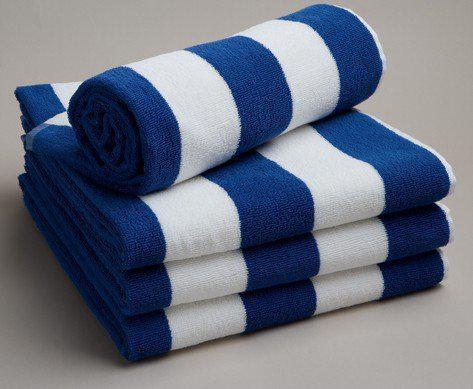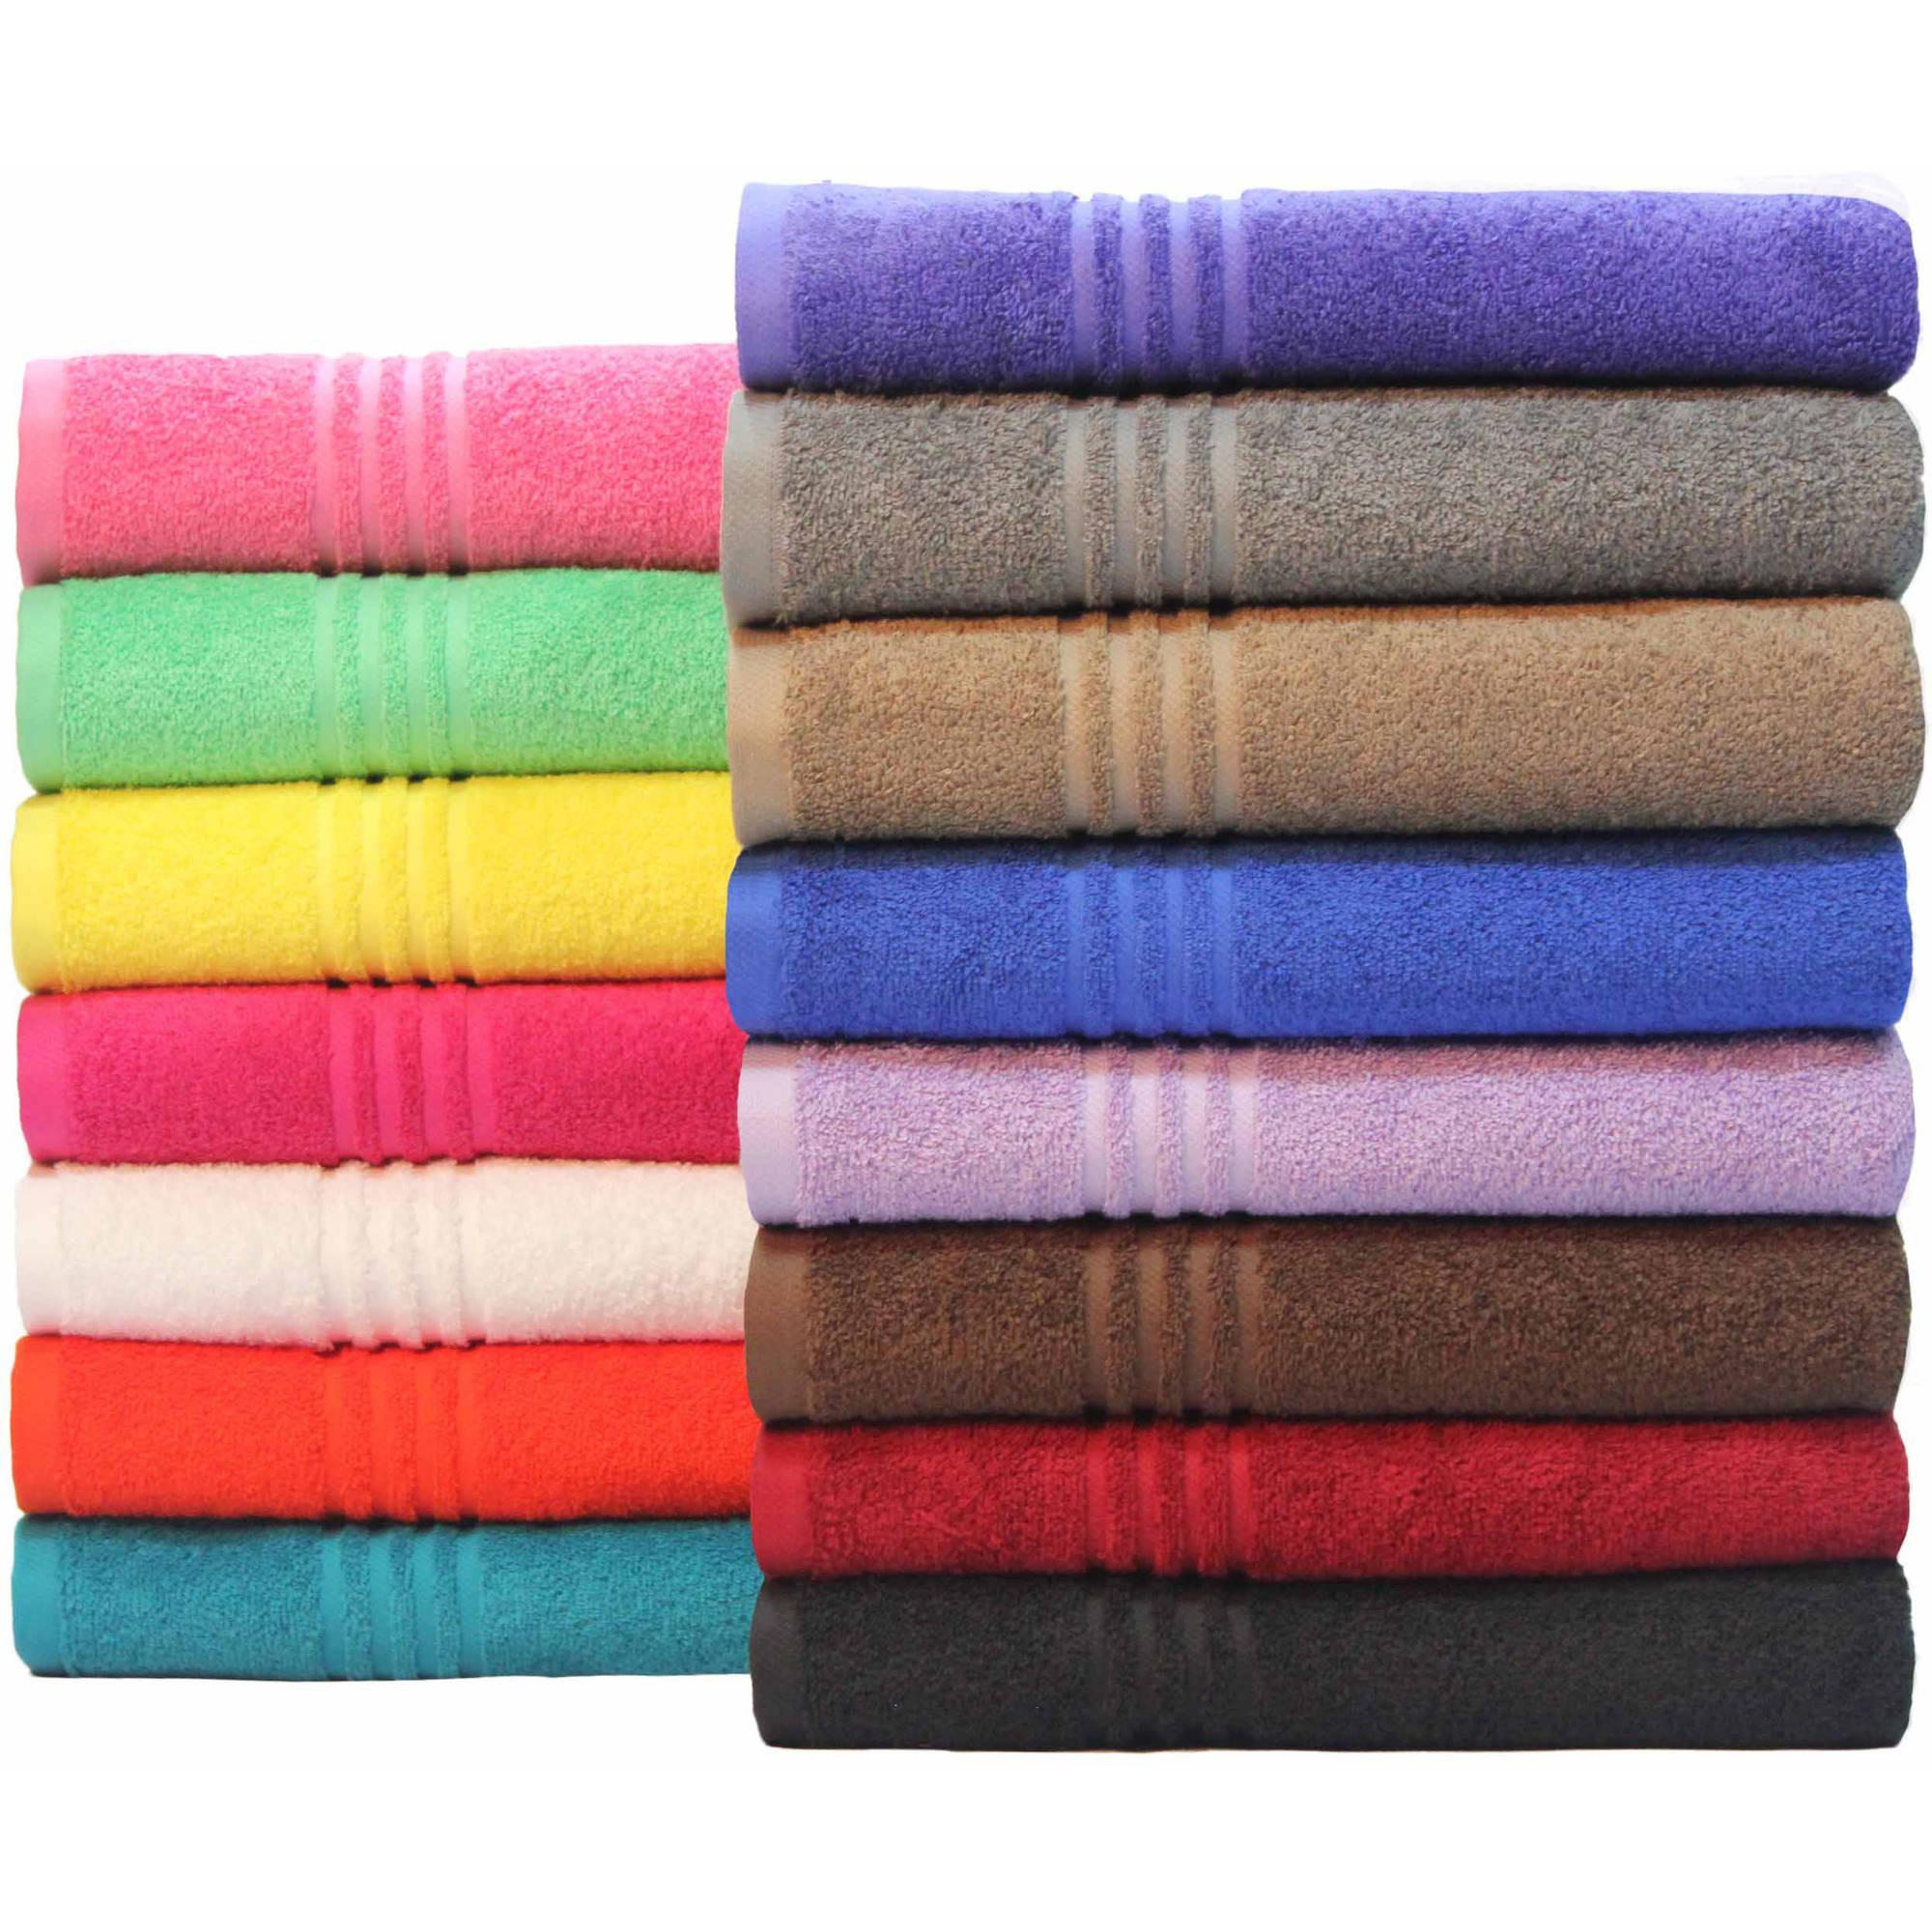The first image is the image on the left, the second image is the image on the right. Given the left and right images, does the statement "In each image there are more than two stacked towels" hold true? Answer yes or no. Yes. The first image is the image on the left, the second image is the image on the right. Evaluate the accuracy of this statement regarding the images: "There is a stack of three white towels in one of the images.". Is it true? Answer yes or no. No. 